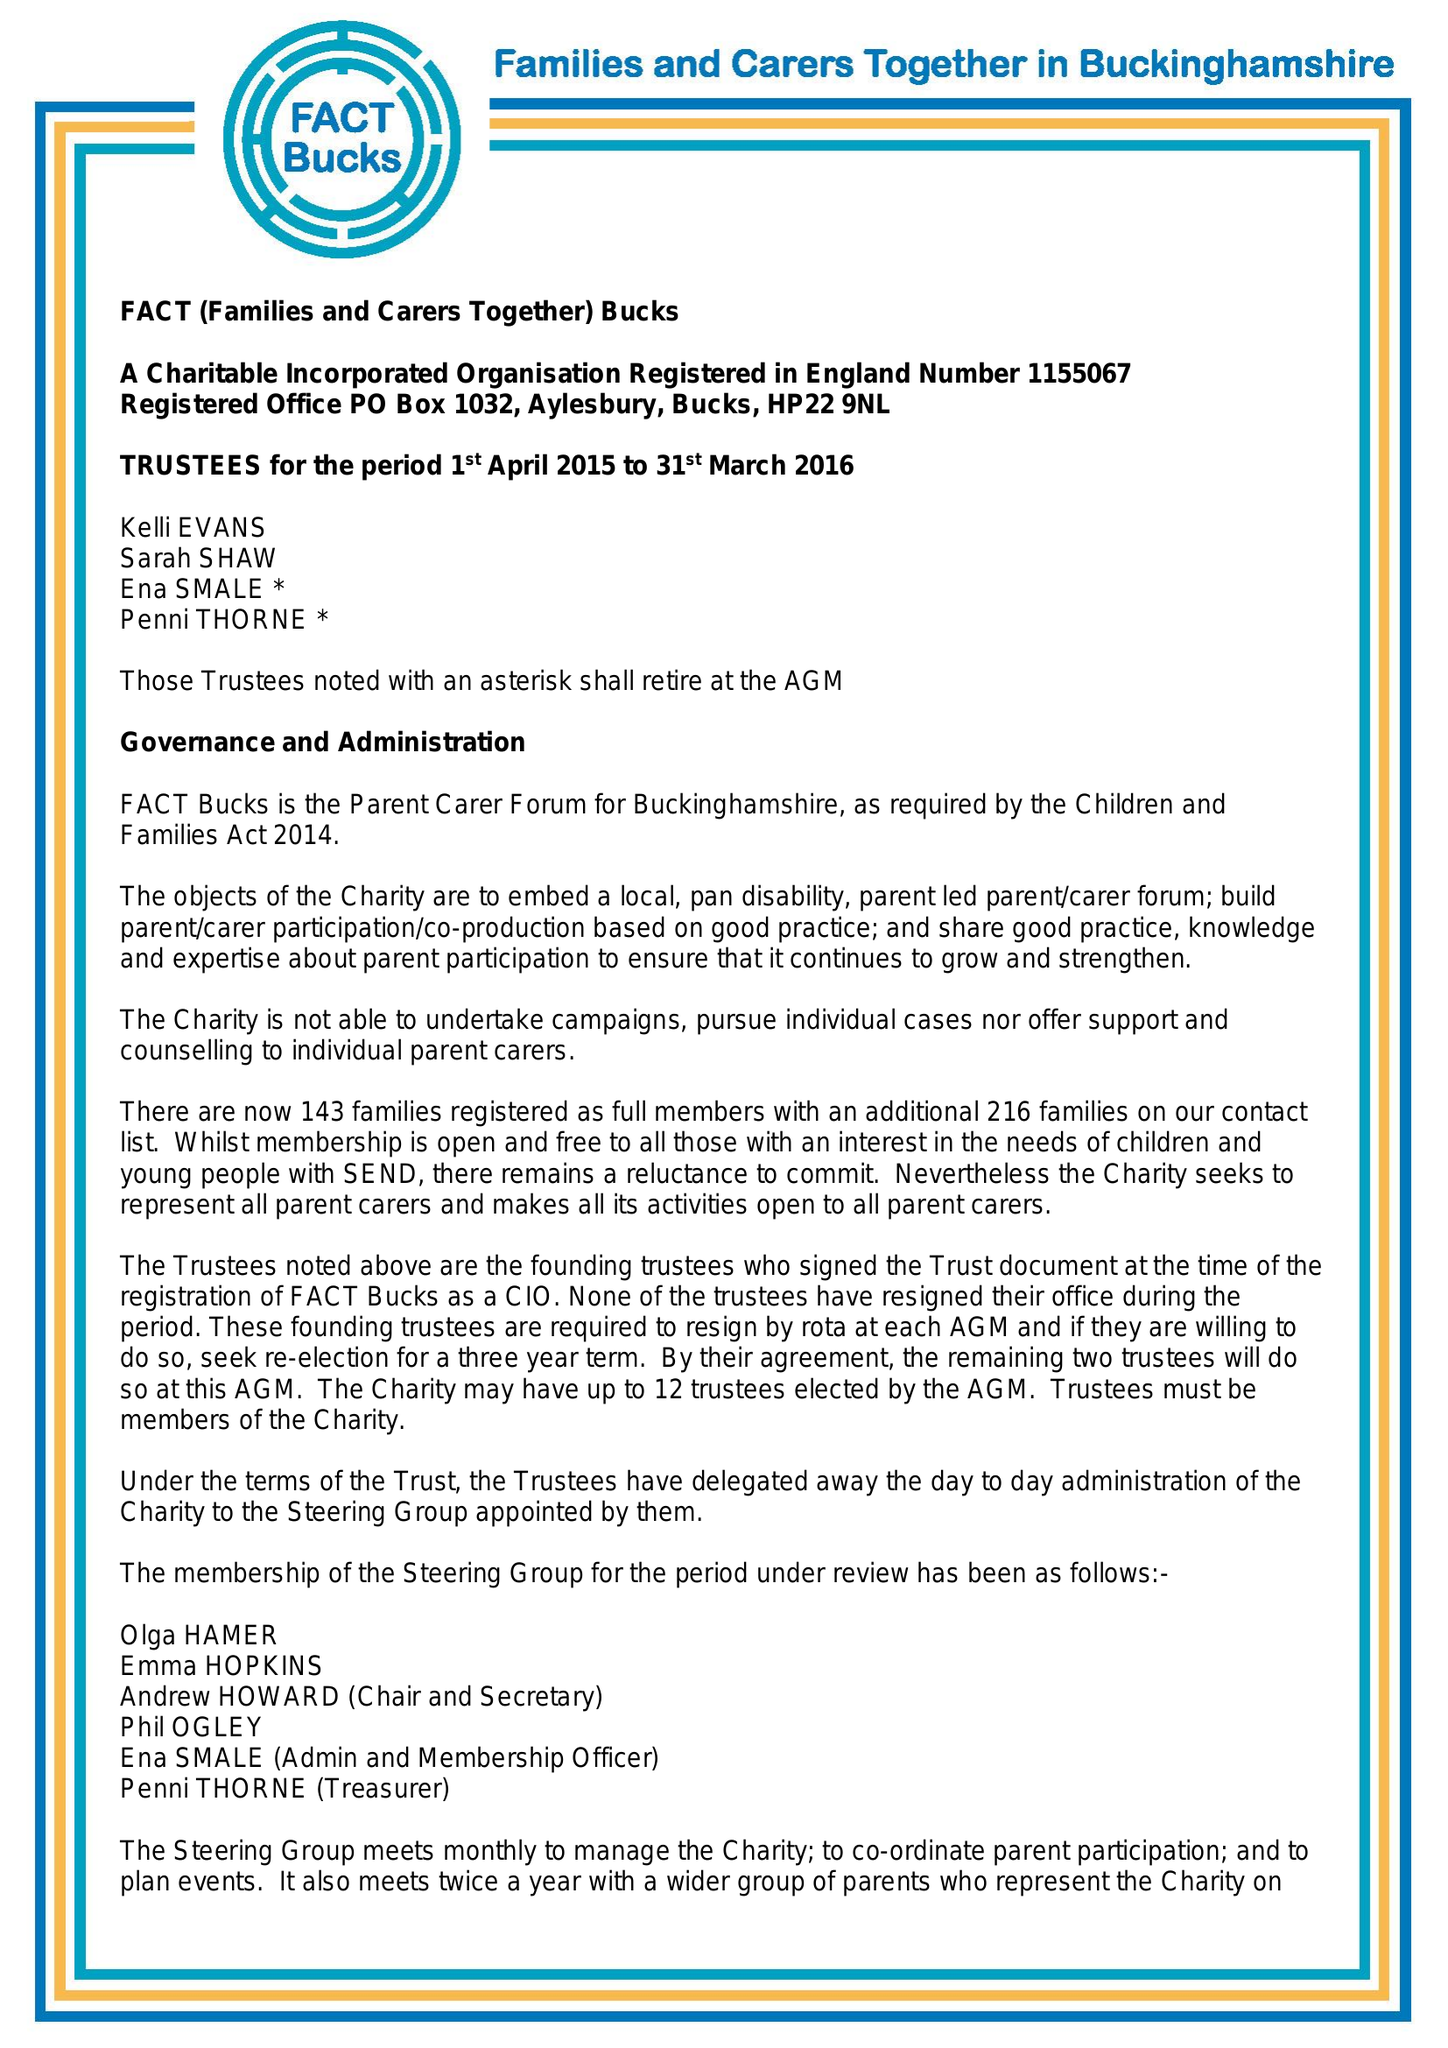What is the value for the income_annually_in_british_pounds?
Answer the question using a single word or phrase. 24999.00 